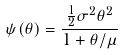Convert formula to latex. <formula><loc_0><loc_0><loc_500><loc_500>\psi ( \theta ) = \frac { \frac { 1 } { 2 } \sigma ^ { 2 } \theta ^ { 2 } } { 1 + \theta / \mu }</formula> 